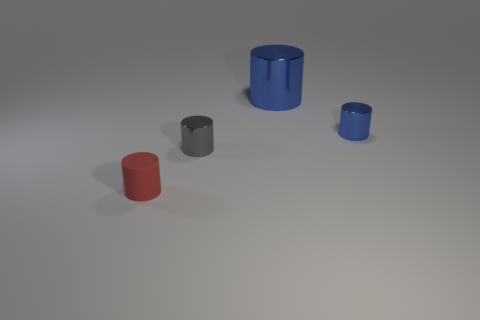Add 3 cylinders. How many objects exist? 7 Subtract 0 cyan spheres. How many objects are left? 4 Subtract all small blue shiny things. Subtract all large blue things. How many objects are left? 2 Add 3 large metallic cylinders. How many large metallic cylinders are left? 4 Add 1 small red matte cylinders. How many small red matte cylinders exist? 2 